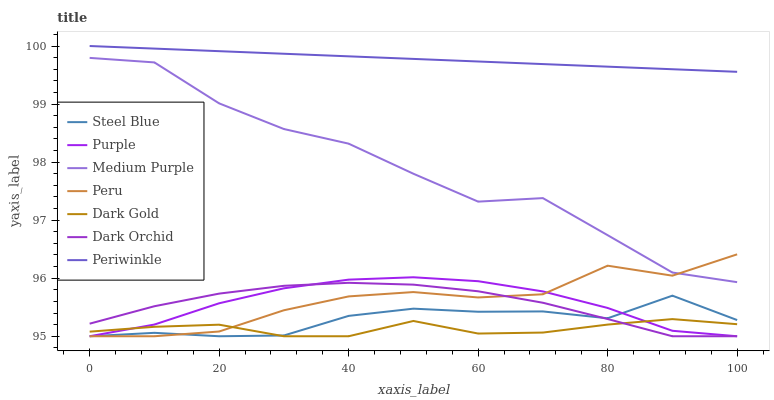Does Dark Gold have the minimum area under the curve?
Answer yes or no. Yes. Does Periwinkle have the maximum area under the curve?
Answer yes or no. Yes. Does Purple have the minimum area under the curve?
Answer yes or no. No. Does Purple have the maximum area under the curve?
Answer yes or no. No. Is Periwinkle the smoothest?
Answer yes or no. Yes. Is Medium Purple the roughest?
Answer yes or no. Yes. Is Purple the smoothest?
Answer yes or no. No. Is Purple the roughest?
Answer yes or no. No. Does Medium Purple have the lowest value?
Answer yes or no. No. Does Periwinkle have the highest value?
Answer yes or no. Yes. Does Purple have the highest value?
Answer yes or no. No. Is Purple less than Periwinkle?
Answer yes or no. Yes. Is Medium Purple greater than Dark Orchid?
Answer yes or no. Yes. Does Steel Blue intersect Dark Gold?
Answer yes or no. Yes. Is Steel Blue less than Dark Gold?
Answer yes or no. No. Is Steel Blue greater than Dark Gold?
Answer yes or no. No. Does Purple intersect Periwinkle?
Answer yes or no. No. 